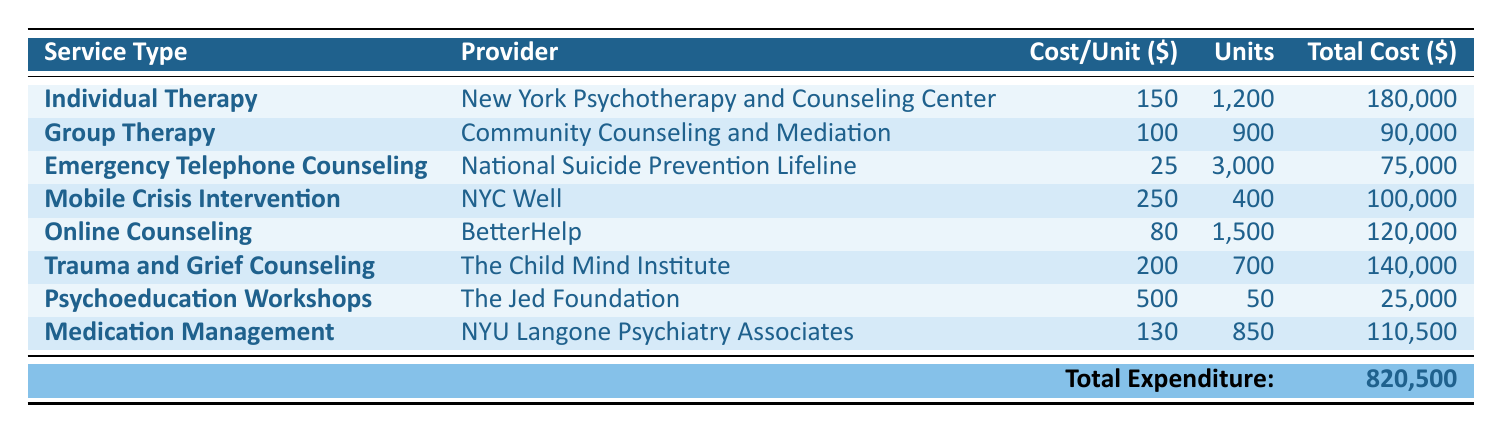What is the total cost of Individual Therapy in 2023? The table shows that the total cost for Individual Therapy, provided by the New York Psychotherapy and Counseling Center, is listed as 180,000 USD.
Answer: 180,000 Which service has the highest cost per session? By comparing the "Cost/Unit" column, Mobile Crisis Intervention at 250 USD per visit is higher than any other service.
Answer: Mobile Crisis Intervention How much was spent on Emergency Telephone Counseling? The table specifies that the total cost for Emergency Telephone Counseling, provided by the National Suicide Prevention Lifeline, is 75,000 USD.
Answer: 75,000 What is the average cost per session for Online Counseling and Trauma and Grief Counseling combined? First, find the total costs for both services: Online Counseling costs 120,000 USD for 1,500 sessions (120,000/1,500 = 80 USD per session), and Trauma and Grief Counseling costs 140,000 USD for 700 sessions (140,000/700 = 200 USD per session). The average is (80 + 200) / 2 = 140 USD.
Answer: 140 Is the total expenditure on all mental health services greater than 800,000 USD? The total expenditure listed in the table sums up to 820,500 USD, which is indeed greater than 800,000 USD.
Answer: Yes What percentage of the total expenditure was spent on Group Therapy? The total expenditure is 820,500 USD and the cost for Group Therapy is 90,000 USD. The percentage is (90,000 / 820,500) × 100 = 10.96%, approximately 11%.
Answer: 11% If we combine the expenses of Mobile Crisis Intervention and Medication Management, what is the total cost? The total costs for Mobile Crisis Intervention are 100,000 USD and for Medication Management are 110,500 USD. Adding these together gives 100,000 + 110,500 = 210,500 USD.
Answer: 210,500 Which provider had the least total expenditure in the table? By checking the "Total Cost" column, Psychoeducation Workshops at 25,000 USD reflects the lowest expenditure among all listed providers.
Answer: The Jed Foundation How many sessions were provided for Online Counseling? The table indicates that there were 1,500 sessions provided for Online Counseling.
Answer: 1,500 